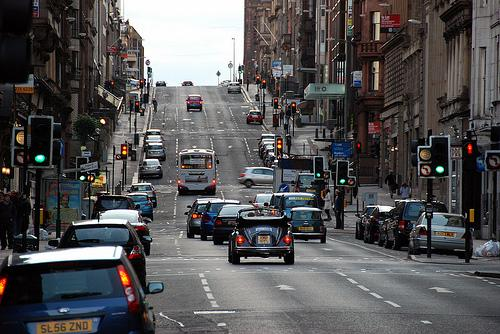Count the total number of cars and buses mentioned in the image description. There are a total of 7 cars and 2 buses. Does the image suggest that the street is situated in a particular city, and if so, which city? Yes, the image suggests that the street is in San Francisco. Evaluate the overall sentiment of the image based on the descriptions given. The overall sentiment of the image seems to be neutral, depicting a typical city street with vehicles, traffic lights, and people. What kind of car is the convertible in the image? A Volkswagen Beetle. Is there any stop light in the image that has changed to green color? Yes. Do any vehicles in the image have their headlights turned on? Yes, cars have their lights on. Point out the object at coordinates (227, 157) and its dimensions. A white car crossing the intersection, Width: 79, Height: 79. Is the sky clear or cloudy in the image? The sky is cloudy. Can you find the construction site barriers closing off part of the sidewalk? This instruction is misleading because there is no mention of construction site barriers in the given information or objects listed. The interrogative sentence will lead the reader to search for something nonexistent in the image. Where is the hot dog stand situated on the busy street? This instruction is misleading because there is no mention of a hot dog stand in the given information, and it is not one of the objects listed. The interrogative sentence prompts the reader to locate something that is not actually present in the image. Notice the billboard displaying a clothing advertisement on top of a building. The instruction is misleading as there is no mention of billboards or advertisements in the information provided. By using a declarative sentence, it implies that the billboard actually exists within the image, which it does not. Choose the correct statement: 1. a bus is parked on the side of the street or 2. a bus is driving down the street. Statement 2: a bus is driving down the street. Describe any anomaly present in the image. There are two traffic lights on a corner. Assess the overall quality of the image. The image quality is average with proper object recognition. Are buildings visible in the image? Yes, buildings line the sides of the street. Look for a large tree with vibrant leaves near the crosswalk. The instruction is misleading as there are no details about a tree within the given information, and a tree is not among the objects listed. The declarative sentence creates a false impression that the tree is in fact easy to find within the image. Can you spot the purple bicycle leaning against the fence on the right side? This instruction is misleading because there is no mention of any bicycle in the information provided, let alone a purple one leaning against a fence. Additionally, the use of the interrogative sentence asks the reader a question, implying that the bicycle exists in the image. What type of sign is present on the building at coordinates (365, 8)? A red and black sign. Describe the interaction between the person and the road. The person is stepping on the road. Is the street in a flat or hilly area? It is a hilly area. Read the text on the yellow license plate. Unable to extraxt text from the image provided. What is the sentiment of people in the image? Neutral, as they are just standing on sidewalks. The fountain with a beautiful sculpture takes center stage in the middle of the intersection. The instruction is misleading as there are no details about a fountain or a sculpture given in the provided information. The declarative sentence implies that the fountain exists and is an important focal point in the image, when it is not. Identify the type of sign near the light at coordinates (410, 160). No left turn sign. Is there any object intersecting the area of the road and the white lines? Yes, a manhole cover. Write a brief description of the scene in the image. There is a busy street in San Francisco with several cars and a bus on the road located on a hill. Cars are parked on the side of the street and people are standing on sidewalks. A person is crossing the road and traffic lights are visible. What are the main colors of the traffic lights? Green, red, and yellow. 